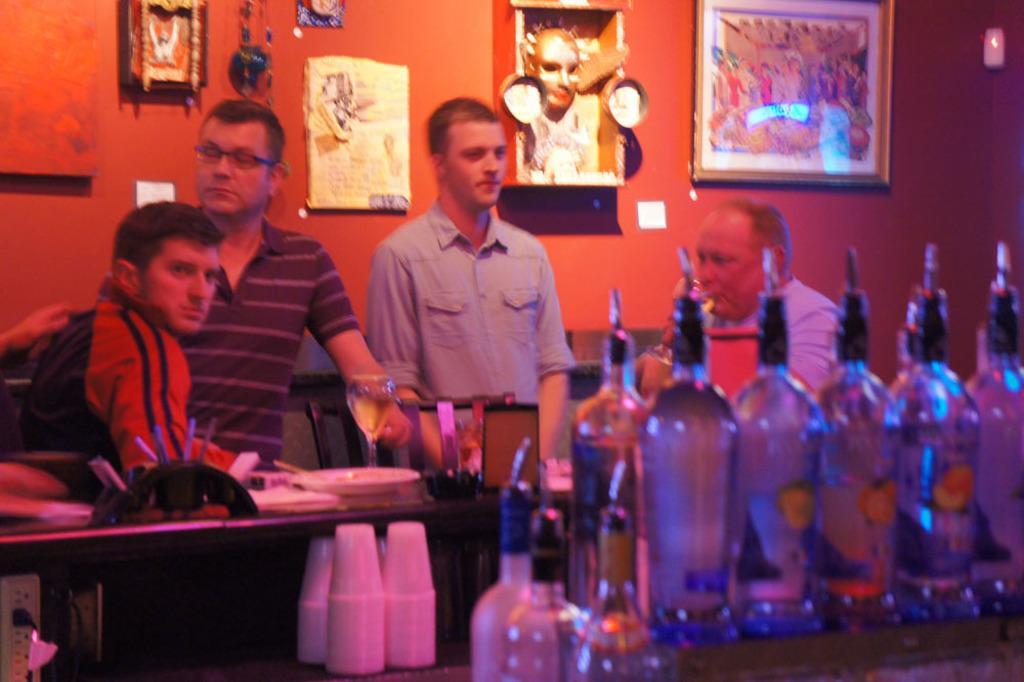How would you summarize this image in a sentence or two? In the picture we can see a four persons, one person sitting next to the other person, and two persons are standing, near to them there is a table and desk, on that we can find a wine bottles and glasses. In the background we can find photo frames to the wall. 